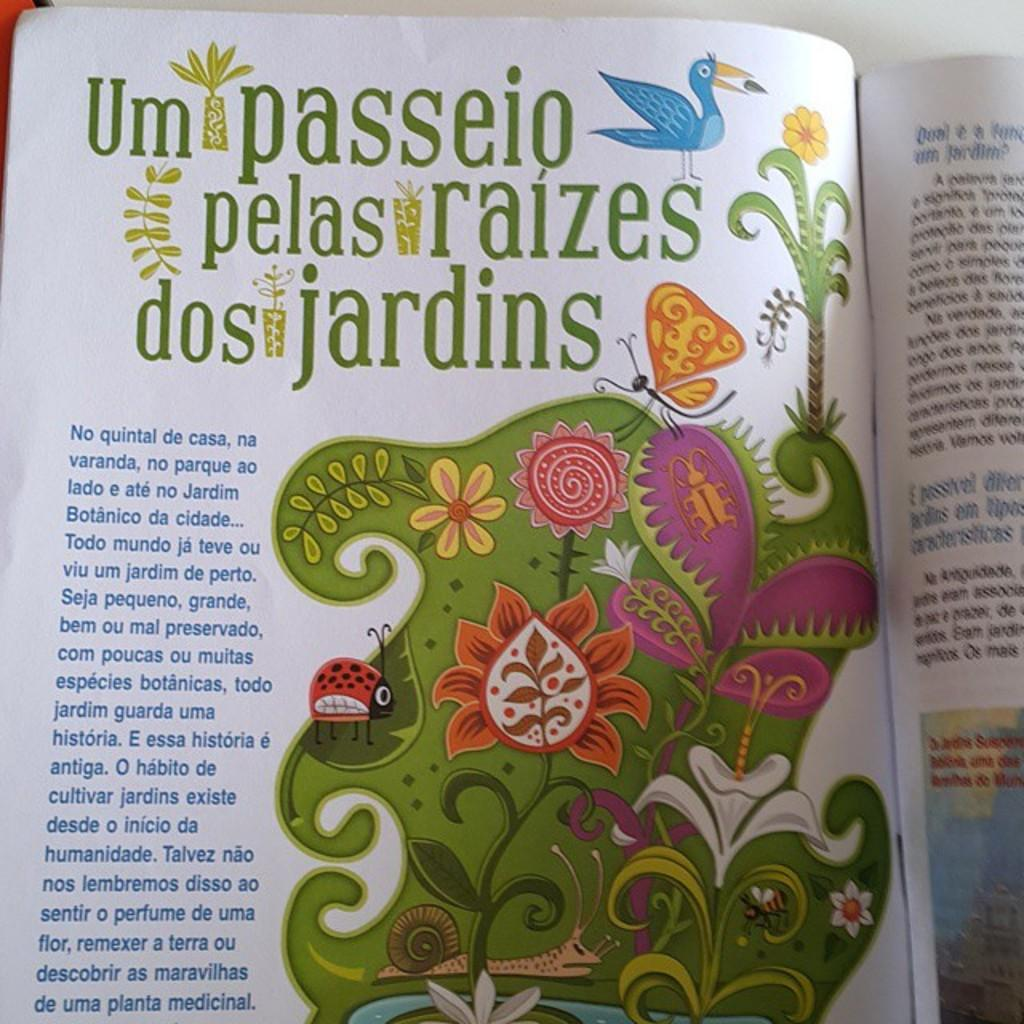<image>
Present a compact description of the photo's key features. A book with colorful illustrations says Um passeio pelas raizes dos jardins. 